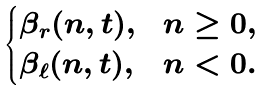<formula> <loc_0><loc_0><loc_500><loc_500>\begin{cases} \beta _ { r } ( n , t ) , & n \geq 0 , \\ \beta _ { \ell } ( n , t ) , & n < 0 . \end{cases}</formula> 